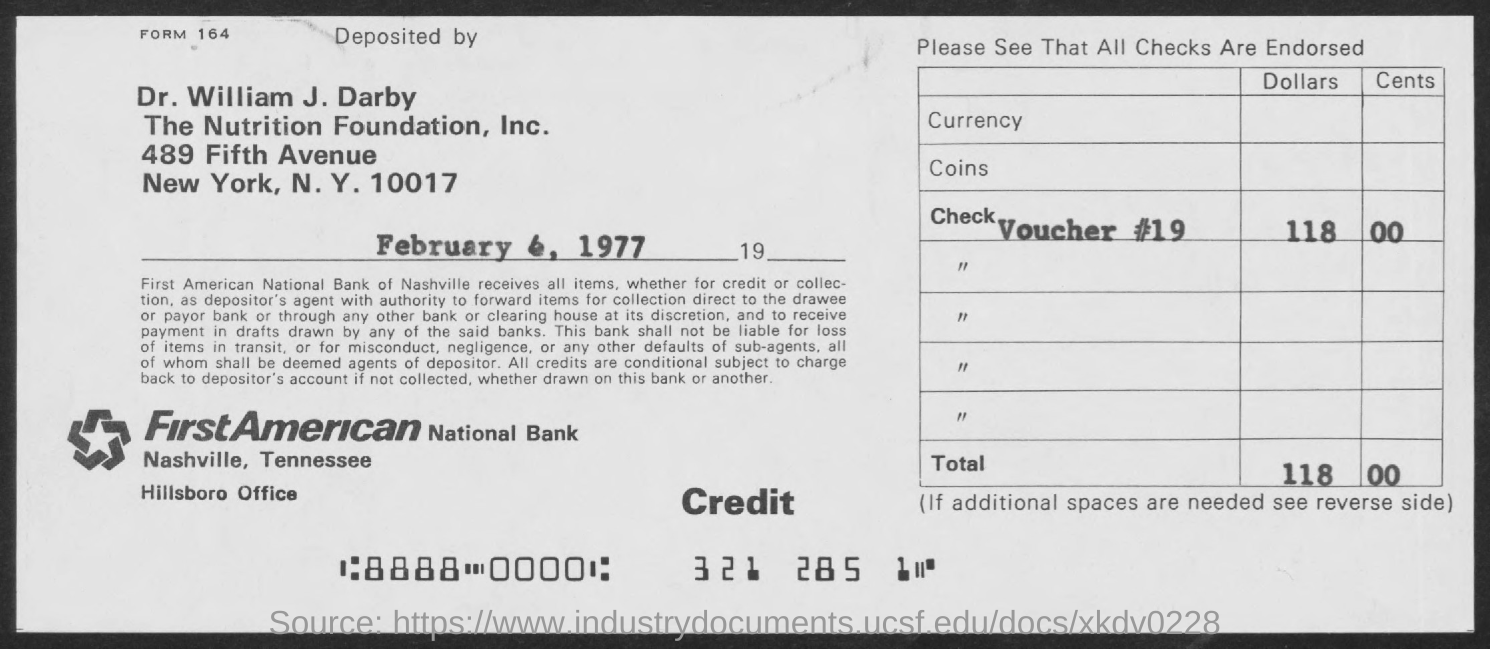Give some essential details in this illustration. The address of the First American National Bank in Nashville, Tennessee is the Hillsboro Office. The First American National Bank is the name of the bank. 